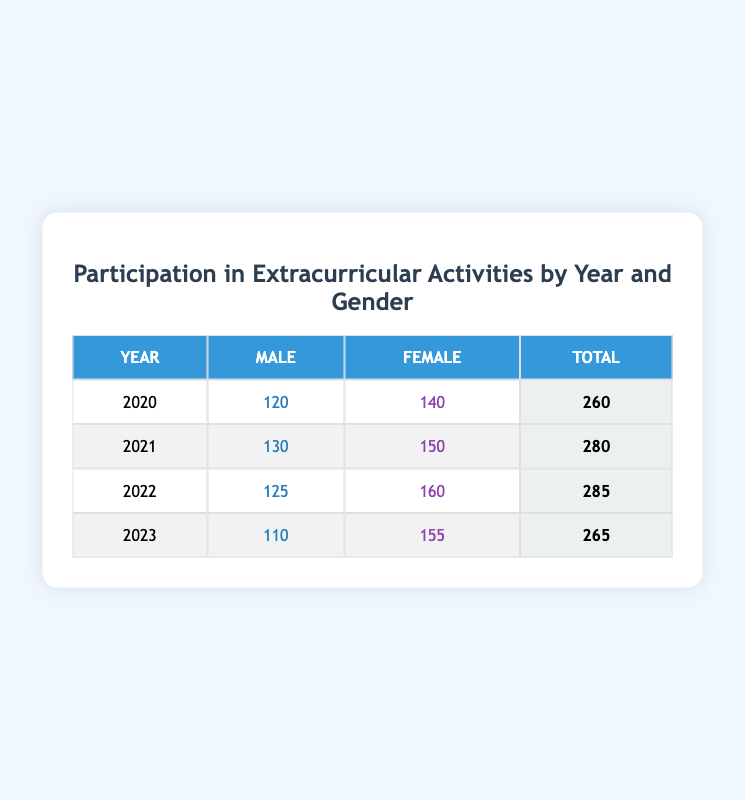What was the total participation of males in 2021? The table shows that the participation of males in 2021 is 130, and there are no additional calculations needed.
Answer: 130 What was the participation difference between male and female students in 2022? For 2022, male participation is 125 and female participation is 160. The difference is calculated as 160 - 125 = 35.
Answer: 35 Which year had the highest total participation in extracurricular activities? The totals for each year are: 2020 - 260, 2021 - 280, 2022 - 285, and 2023 - 265. 2022 has the highest total with 285.
Answer: 2022 Is the participation of female students increasing over the years? The female participation numbers are 140 (2020), 150 (2021), 160 (2022), and 155 (2023). While it increased from 2020 to 2022, it decreased from 2022 to 2023, indicating it's not consistently increasing.
Answer: No What is the average participation of male students from 2020 to 2023? The male participation values over the four years are 120, 130, 125, and 110. The sum is 120 + 130 + 125 + 110 = 485. To calculate the average, divide by 4: 485 / 4 = 121.25.
Answer: 121.25 